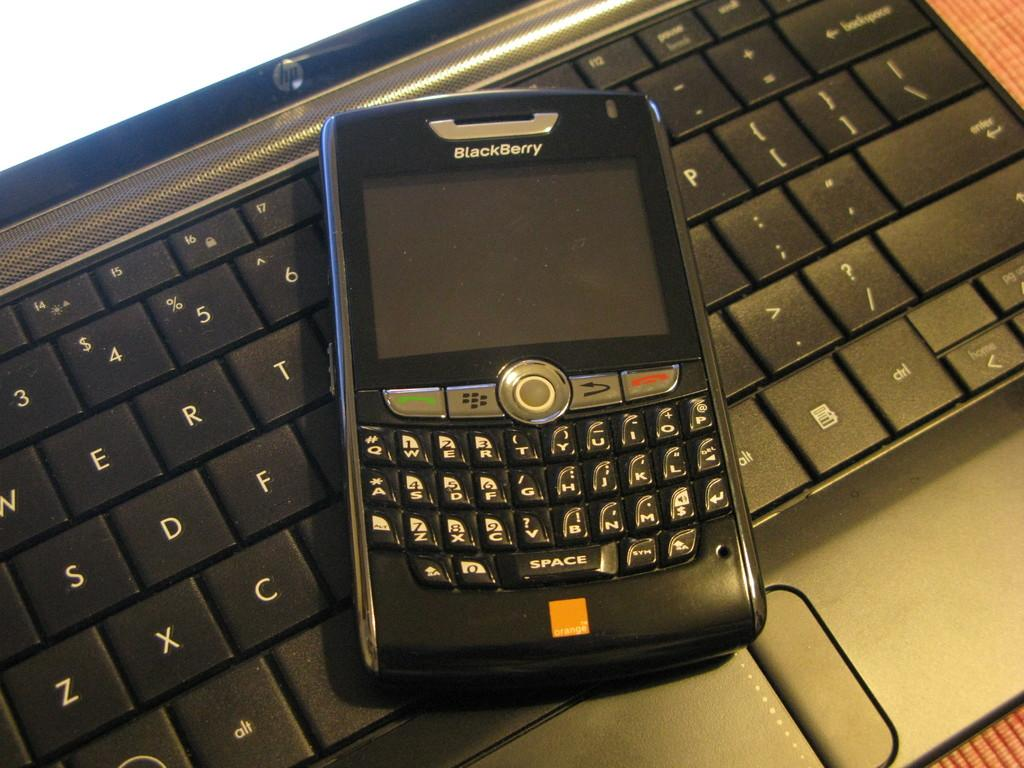<image>
Render a clear and concise summary of the photo. A Blackberry phone is on top of a keyboard. 